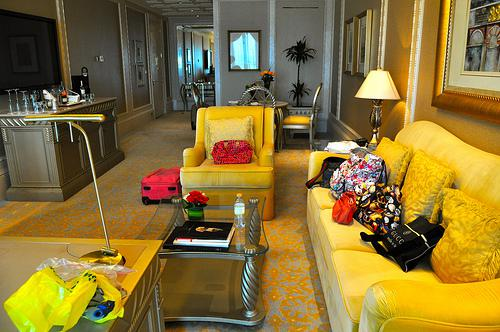Question: where is the book?
Choices:
A. Library.
B. Bag.
C. On the table.
D. School.
Answer with the letter. Answer: C Question: why is the lamp on?
Choices:
A. Decoration.
B. Mood.
C. Provide light.
D. Scenery.
Answer with the letter. Answer: C Question: how many yellow pillows on the couch?
Choices:
A. One.
B. Three.
C. Two.
D. Four.
Answer with the letter. Answer: B 